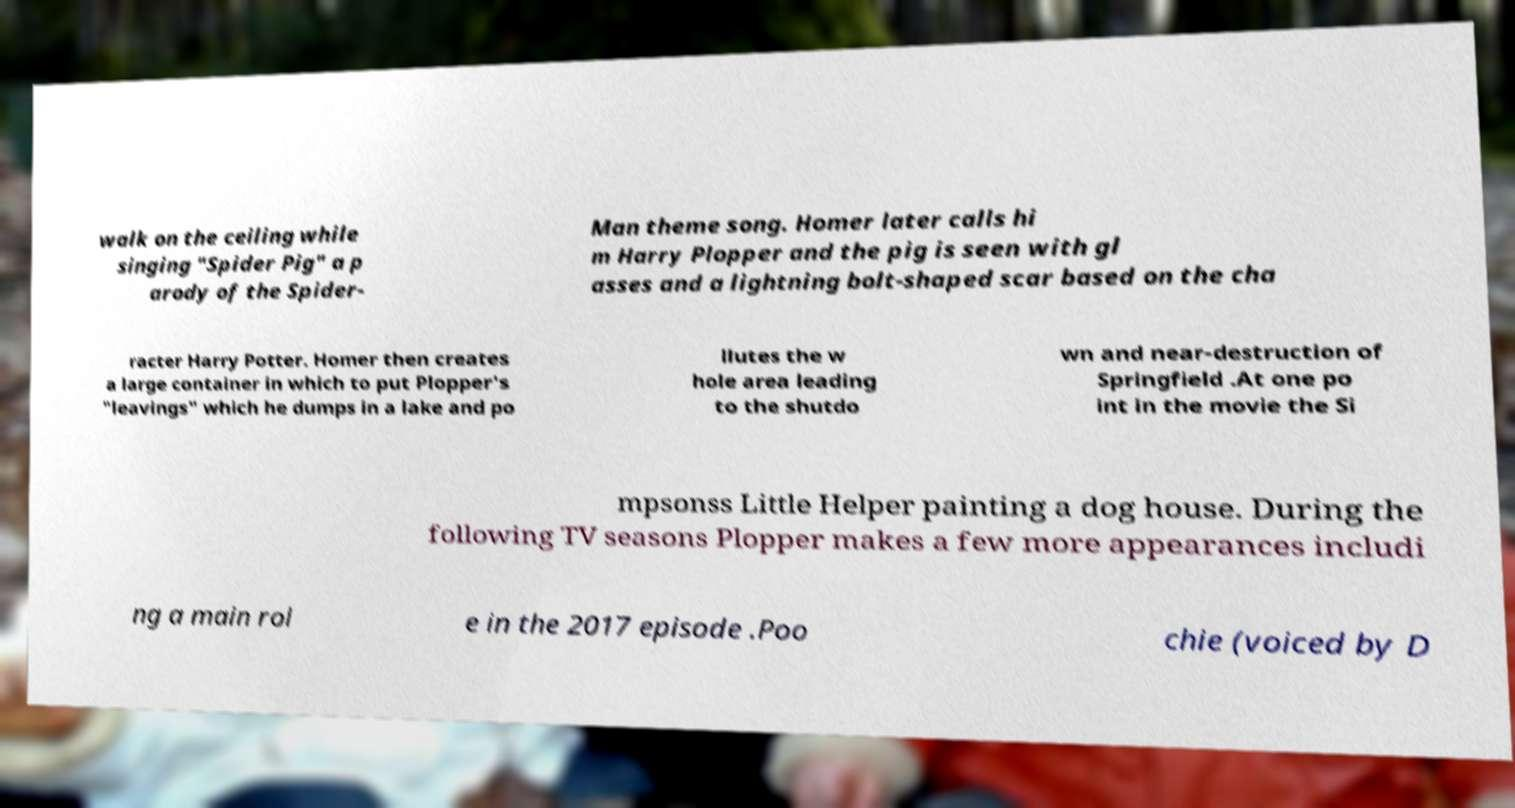Can you accurately transcribe the text from the provided image for me? walk on the ceiling while singing "Spider Pig" a p arody of the Spider- Man theme song. Homer later calls hi m Harry Plopper and the pig is seen with gl asses and a lightning bolt-shaped scar based on the cha racter Harry Potter. Homer then creates a large container in which to put Plopper's "leavings" which he dumps in a lake and po llutes the w hole area leading to the shutdo wn and near-destruction of Springfield .At one po int in the movie the Si mpsonss Little Helper painting a dog house. During the following TV seasons Plopper makes a few more appearances includi ng a main rol e in the 2017 episode .Poo chie (voiced by D 